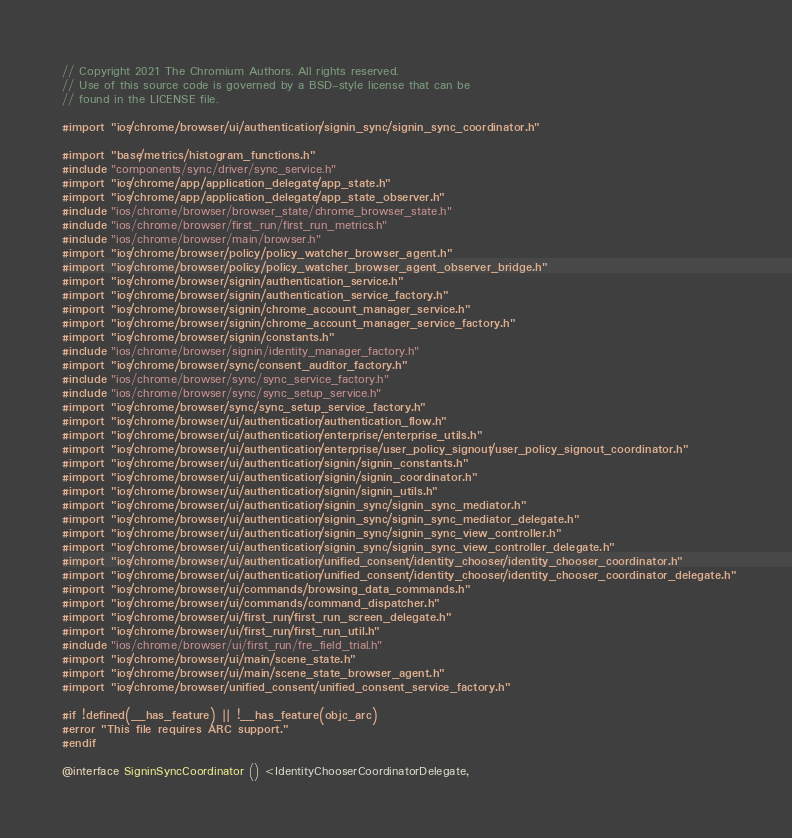<code> <loc_0><loc_0><loc_500><loc_500><_ObjectiveC_>// Copyright 2021 The Chromium Authors. All rights reserved.
// Use of this source code is governed by a BSD-style license that can be
// found in the LICENSE file.

#import "ios/chrome/browser/ui/authentication/signin_sync/signin_sync_coordinator.h"

#import "base/metrics/histogram_functions.h"
#include "components/sync/driver/sync_service.h"
#import "ios/chrome/app/application_delegate/app_state.h"
#import "ios/chrome/app/application_delegate/app_state_observer.h"
#include "ios/chrome/browser/browser_state/chrome_browser_state.h"
#include "ios/chrome/browser/first_run/first_run_metrics.h"
#include "ios/chrome/browser/main/browser.h"
#import "ios/chrome/browser/policy/policy_watcher_browser_agent.h"
#import "ios/chrome/browser/policy/policy_watcher_browser_agent_observer_bridge.h"
#import "ios/chrome/browser/signin/authentication_service.h"
#import "ios/chrome/browser/signin/authentication_service_factory.h"
#import "ios/chrome/browser/signin/chrome_account_manager_service.h"
#import "ios/chrome/browser/signin/chrome_account_manager_service_factory.h"
#import "ios/chrome/browser/signin/constants.h"
#include "ios/chrome/browser/signin/identity_manager_factory.h"
#import "ios/chrome/browser/sync/consent_auditor_factory.h"
#include "ios/chrome/browser/sync/sync_service_factory.h"
#include "ios/chrome/browser/sync/sync_setup_service.h"
#import "ios/chrome/browser/sync/sync_setup_service_factory.h"
#import "ios/chrome/browser/ui/authentication/authentication_flow.h"
#import "ios/chrome/browser/ui/authentication/enterprise/enterprise_utils.h"
#import "ios/chrome/browser/ui/authentication/enterprise/user_policy_signout/user_policy_signout_coordinator.h"
#import "ios/chrome/browser/ui/authentication/signin/signin_constants.h"
#import "ios/chrome/browser/ui/authentication/signin/signin_coordinator.h"
#import "ios/chrome/browser/ui/authentication/signin/signin_utils.h"
#import "ios/chrome/browser/ui/authentication/signin_sync/signin_sync_mediator.h"
#import "ios/chrome/browser/ui/authentication/signin_sync/signin_sync_mediator_delegate.h"
#import "ios/chrome/browser/ui/authentication/signin_sync/signin_sync_view_controller.h"
#import "ios/chrome/browser/ui/authentication/signin_sync/signin_sync_view_controller_delegate.h"
#import "ios/chrome/browser/ui/authentication/unified_consent/identity_chooser/identity_chooser_coordinator.h"
#import "ios/chrome/browser/ui/authentication/unified_consent/identity_chooser/identity_chooser_coordinator_delegate.h"
#import "ios/chrome/browser/ui/commands/browsing_data_commands.h"
#import "ios/chrome/browser/ui/commands/command_dispatcher.h"
#import "ios/chrome/browser/ui/first_run/first_run_screen_delegate.h"
#import "ios/chrome/browser/ui/first_run/first_run_util.h"
#include "ios/chrome/browser/ui/first_run/fre_field_trial.h"
#import "ios/chrome/browser/ui/main/scene_state.h"
#import "ios/chrome/browser/ui/main/scene_state_browser_agent.h"
#import "ios/chrome/browser/unified_consent/unified_consent_service_factory.h"

#if !defined(__has_feature) || !__has_feature(objc_arc)
#error "This file requires ARC support."
#endif

@interface SigninSyncCoordinator () <IdentityChooserCoordinatorDelegate,</code> 